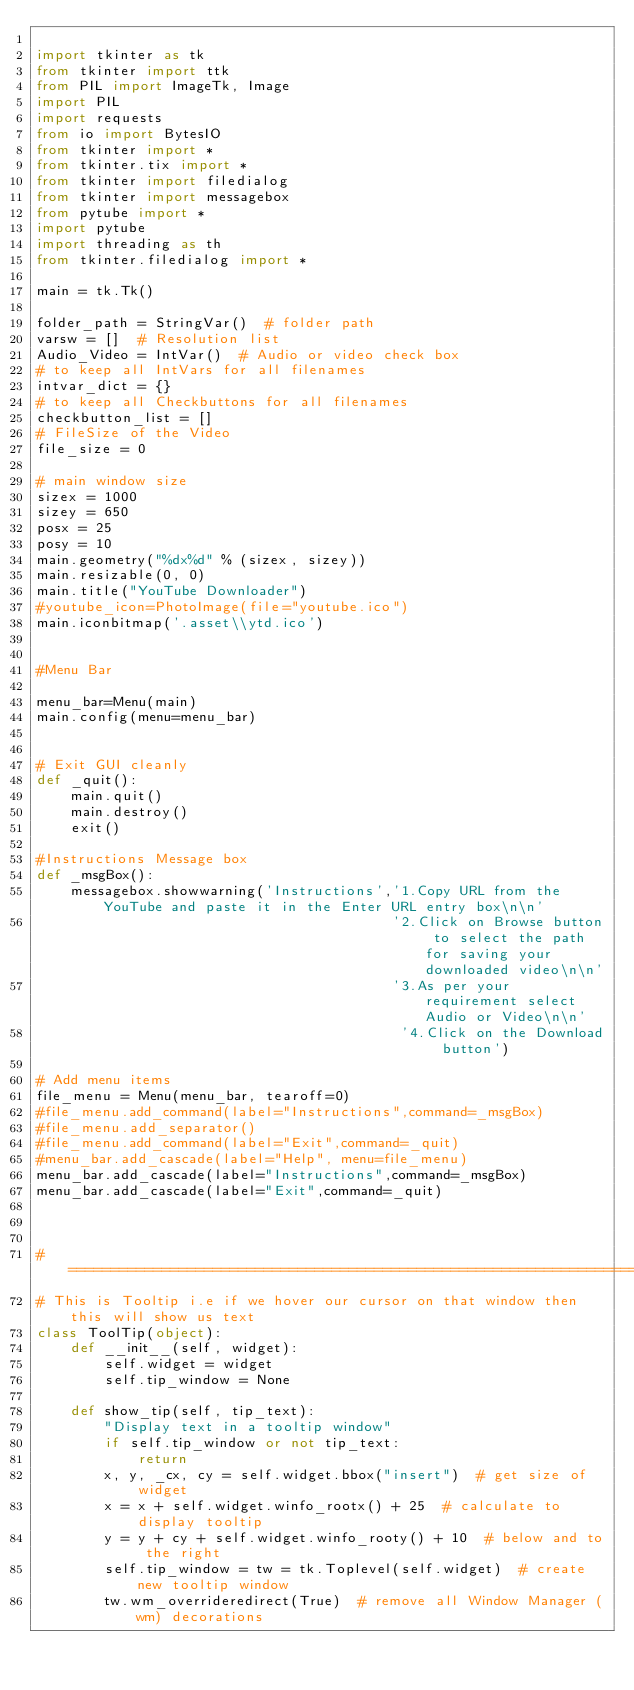<code> <loc_0><loc_0><loc_500><loc_500><_Python_>
import tkinter as tk
from tkinter import ttk
from PIL import ImageTk, Image
import PIL
import requests
from io import BytesIO
from tkinter import *
from tkinter.tix import *
from tkinter import filedialog
from tkinter import messagebox
from pytube import *
import pytube
import threading as th
from tkinter.filedialog import *

main = tk.Tk()

folder_path = StringVar()  # folder path
varsw = []  # Resolution list
Audio_Video = IntVar()  # Audio or video check box
# to keep all IntVars for all filenames
intvar_dict = {}
# to keep all Checkbuttons for all filenames
checkbutton_list = []
# FileSize of the Video
file_size = 0

# main window size
sizex = 1000
sizey = 650
posx = 25
posy = 10
main.geometry("%dx%d" % (sizex, sizey))
main.resizable(0, 0)
main.title("YouTube Downloader")
#youtube_icon=PhotoImage(file="youtube.ico")
main.iconbitmap('.asset\\ytd.ico')


#Menu Bar

menu_bar=Menu(main)
main.config(menu=menu_bar)


# Exit GUI cleanly
def _quit():
    main.quit()
    main.destroy()
    exit()

#Instructions Message box
def _msgBox():
    messagebox.showwarning('Instructions','1.Copy URL from the YouTube and paste it in the Enter URL entry box\n\n'
                                          '2.Click on Browse button to select the path for saving your downloaded video\n\n'
                                          '3.As per your requirement select Audio or Video\n\n'
                                           '4.Click on the Download button')

# Add menu items
file_menu = Menu(menu_bar, tearoff=0)
#file_menu.add_command(label="Instructions",command=_msgBox)
#file_menu.add_separator()
#file_menu.add_command(label="Exit",command=_quit)
#menu_bar.add_cascade(label="Help", menu=file_menu)
menu_bar.add_cascade(label="Instructions",command=_msgBox)
menu_bar.add_cascade(label="Exit",command=_quit)



# ===================================================================
# This is Tooltip i.e if we hover our cursor on that window then this will show us text
class ToolTip(object):
    def __init__(self, widget):
        self.widget = widget
        self.tip_window = None

    def show_tip(self, tip_text):
        "Display text in a tooltip window"
        if self.tip_window or not tip_text:
            return
        x, y, _cx, cy = self.widget.bbox("insert")  # get size of widget
        x = x + self.widget.winfo_rootx() + 25  # calculate to display tooltip
        y = y + cy + self.widget.winfo_rooty() + 10  # below and to the right
        self.tip_window = tw = tk.Toplevel(self.widget)  # create new tooltip window
        tw.wm_overrideredirect(True)  # remove all Window Manager (wm) decorations</code> 